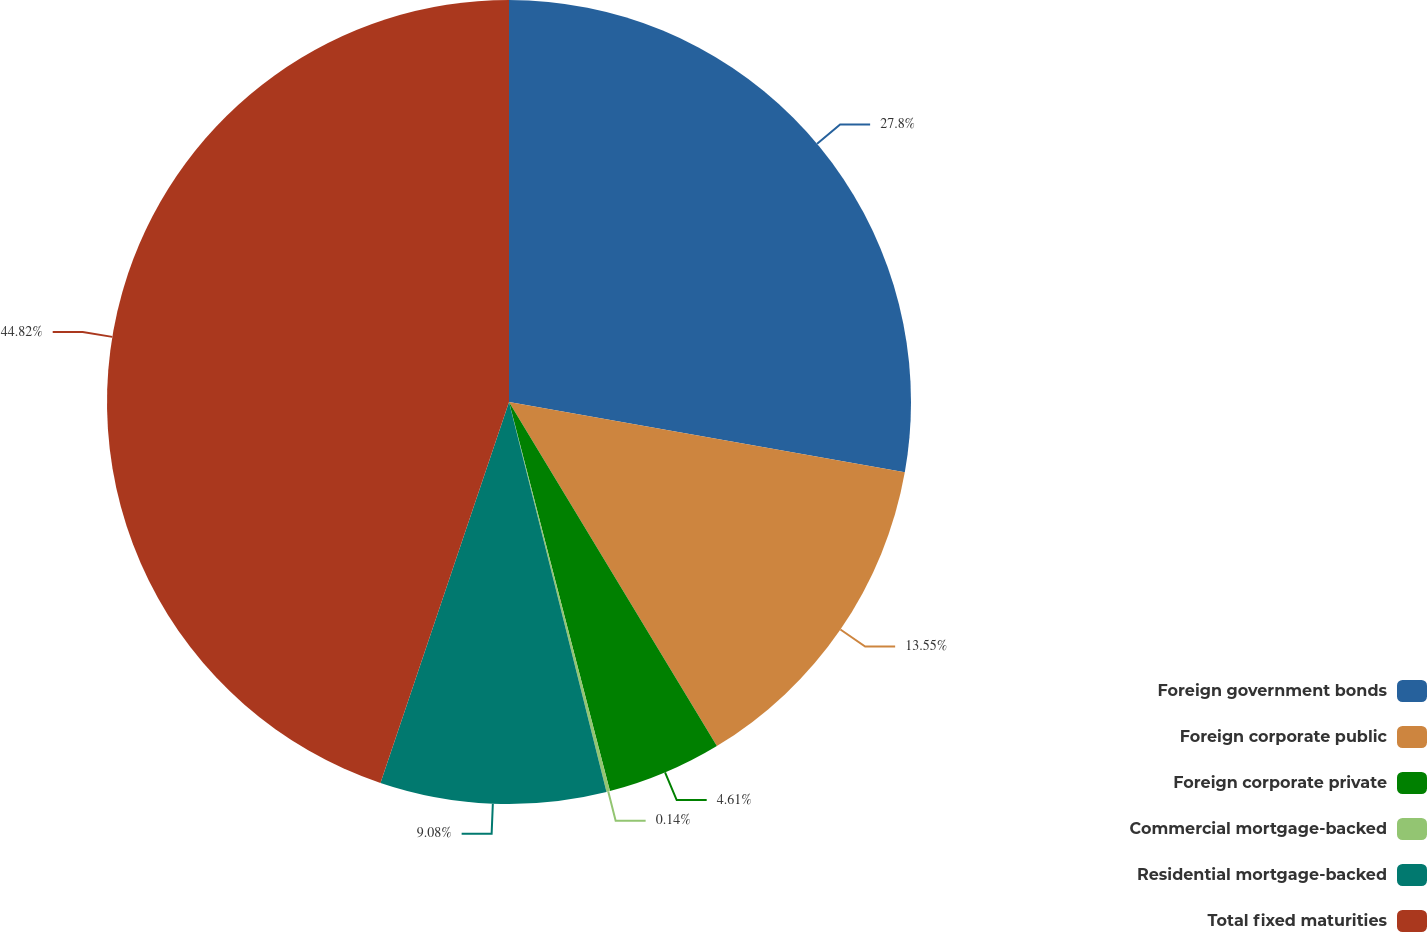Convert chart to OTSL. <chart><loc_0><loc_0><loc_500><loc_500><pie_chart><fcel>Foreign government bonds<fcel>Foreign corporate public<fcel>Foreign corporate private<fcel>Commercial mortgage-backed<fcel>Residential mortgage-backed<fcel>Total fixed maturities<nl><fcel>27.8%<fcel>13.55%<fcel>4.61%<fcel>0.14%<fcel>9.08%<fcel>44.82%<nl></chart> 